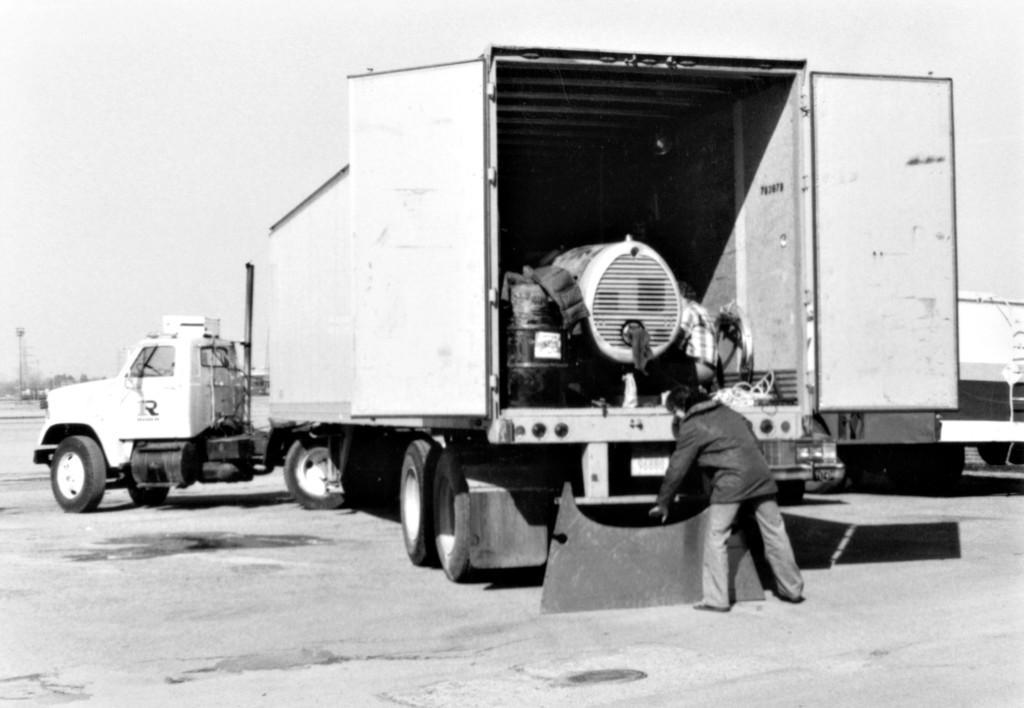Describe this image in one or two sentences. In this image, we can see a truck. Here we can see two people. At the bottom, we can see a road. Background there is a sky. Here we can see few objects in the vehicle. 